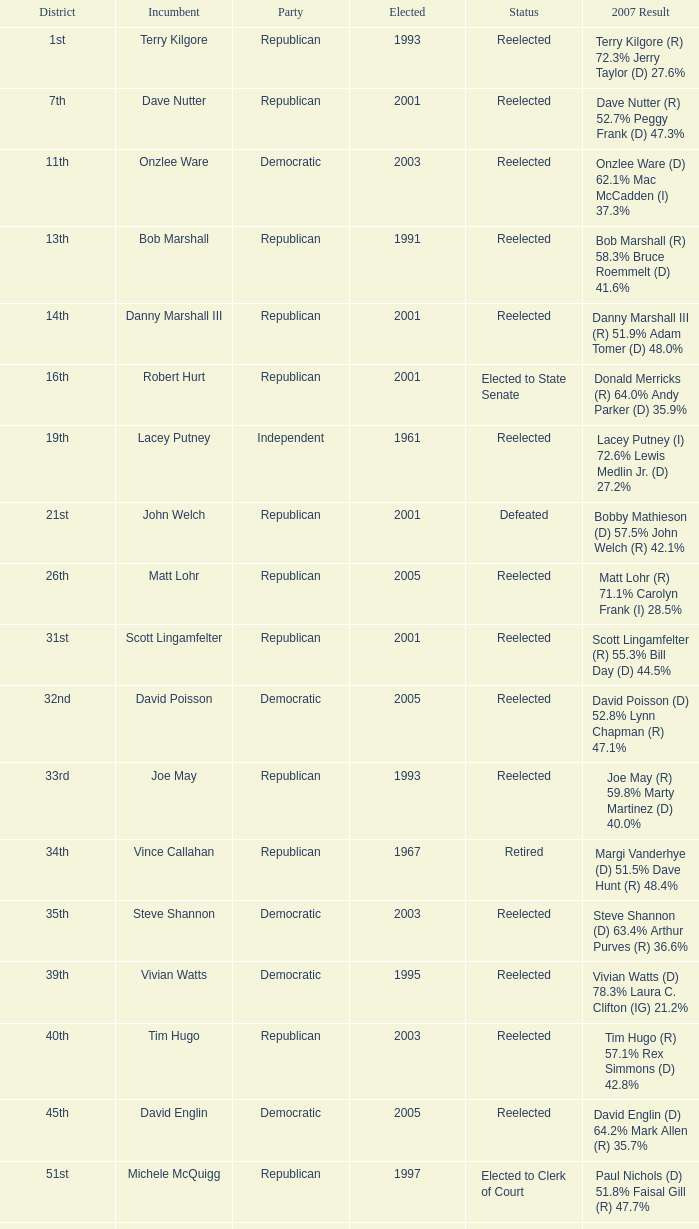What was the last year someone was elected to the 14th district? 2001.0. Could you parse the entire table? {'header': ['District', 'Incumbent', 'Party', 'Elected', 'Status', '2007 Result'], 'rows': [['1st', 'Terry Kilgore', 'Republican', '1993', 'Reelected', 'Terry Kilgore (R) 72.3% Jerry Taylor (D) 27.6%'], ['7th', 'Dave Nutter', 'Republican', '2001', 'Reelected', 'Dave Nutter (R) 52.7% Peggy Frank (D) 47.3%'], ['11th', 'Onzlee Ware', 'Democratic', '2003', 'Reelected', 'Onzlee Ware (D) 62.1% Mac McCadden (I) 37.3%'], ['13th', 'Bob Marshall', 'Republican', '1991', 'Reelected', 'Bob Marshall (R) 58.3% Bruce Roemmelt (D) 41.6%'], ['14th', 'Danny Marshall III', 'Republican', '2001', 'Reelected', 'Danny Marshall III (R) 51.9% Adam Tomer (D) 48.0%'], ['16th', 'Robert Hurt', 'Republican', '2001', 'Elected to State Senate', 'Donald Merricks (R) 64.0% Andy Parker (D) 35.9%'], ['19th', 'Lacey Putney', 'Independent', '1961', 'Reelected', 'Lacey Putney (I) 72.6% Lewis Medlin Jr. (D) 27.2%'], ['21st', 'John Welch', 'Republican', '2001', 'Defeated', 'Bobby Mathieson (D) 57.5% John Welch (R) 42.1%'], ['26th', 'Matt Lohr', 'Republican', '2005', 'Reelected', 'Matt Lohr (R) 71.1% Carolyn Frank (I) 28.5%'], ['31st', 'Scott Lingamfelter', 'Republican', '2001', 'Reelected', 'Scott Lingamfelter (R) 55.3% Bill Day (D) 44.5%'], ['32nd', 'David Poisson', 'Democratic', '2005', 'Reelected', 'David Poisson (D) 52.8% Lynn Chapman (R) 47.1%'], ['33rd', 'Joe May', 'Republican', '1993', 'Reelected', 'Joe May (R) 59.8% Marty Martinez (D) 40.0%'], ['34th', 'Vince Callahan', 'Republican', '1967', 'Retired', 'Margi Vanderhye (D) 51.5% Dave Hunt (R) 48.4%'], ['35th', 'Steve Shannon', 'Democratic', '2003', 'Reelected', 'Steve Shannon (D) 63.4% Arthur Purves (R) 36.6%'], ['39th', 'Vivian Watts', 'Democratic', '1995', 'Reelected', 'Vivian Watts (D) 78.3% Laura C. Clifton (IG) 21.2%'], ['40th', 'Tim Hugo', 'Republican', '2003', 'Reelected', 'Tim Hugo (R) 57.1% Rex Simmons (D) 42.8%'], ['45th', 'David Englin', 'Democratic', '2005', 'Reelected', 'David Englin (D) 64.2% Mark Allen (R) 35.7%'], ['51st', 'Michele McQuigg', 'Republican', '1997', 'Elected to Clerk of Court', 'Paul Nichols (D) 51.8% Faisal Gill (R) 47.7%'], ['54th', 'Bobby Orrock', 'Republican', '1989', 'Reelected', 'Bobby Orrock (R) 73.7% Kimbra Kincheloe (I) 26.2%'], ['56th', 'Bill Janis', 'Republican', '2001', 'Reelected', 'Bill Janis (R) 65.9% Will Shaw (D) 34.0%'], ['59th', 'Watkins Abbitt', 'Independent', '1985', 'Reelected', 'Watkins Abbitt (I) 60.2% Connie Brennan (D) 39.7%'], ['67th', 'Chuck Caputo', 'Democratic', '2005', 'Reelected', 'Chuck Caputo (D) 52.7% Marc Cadin (R) 47.3%'], ['69th', 'Frank Hall', 'Democratic', '1975', 'Reelected', 'Frank Hall (D) 82.8% Ray Gargiulo (R) 17.0%'], ['72nd', 'Jack Reid', 'Republican', '1989', 'Retired', 'Jimmie Massie (R) 67.2% Tom Herbert (D) 32.7%'], ['78th', 'John Cosgrove', 'Republican', '2001', 'Reelected', 'John Cosgrove (R) 61.7% Mick Meyer (D) 38.2%'], ['82nd', 'Bob Purkey', 'Republican', '1985', 'Reelected', 'Bob Purkey (R) 60.6% Bob MacIver (D) 39.2%'], ['83rd', 'Leo Wardrup', 'Republican', '1991', 'Retired', 'Joe Bouchard (D) 50.6% Chris Stolle (R) 49.2%'], ['86th', 'Tom Rust', 'Republican', '2001', 'Reelected', 'Tom Rust (R) 52.8% Jay Donahue (D) 47.1%'], ['87th', 'Paula Miller', 'Democratic', '2005', 'Reelected', 'Paula Miller (D) 54.0% Hank Giffin (R) 45.8%'], ['88th', 'Mark Cole', 'Republican', '2001', 'Reelected', 'Mark Cole (R) 62.2% Carlos Del Toro (D) 37.6%']]} 